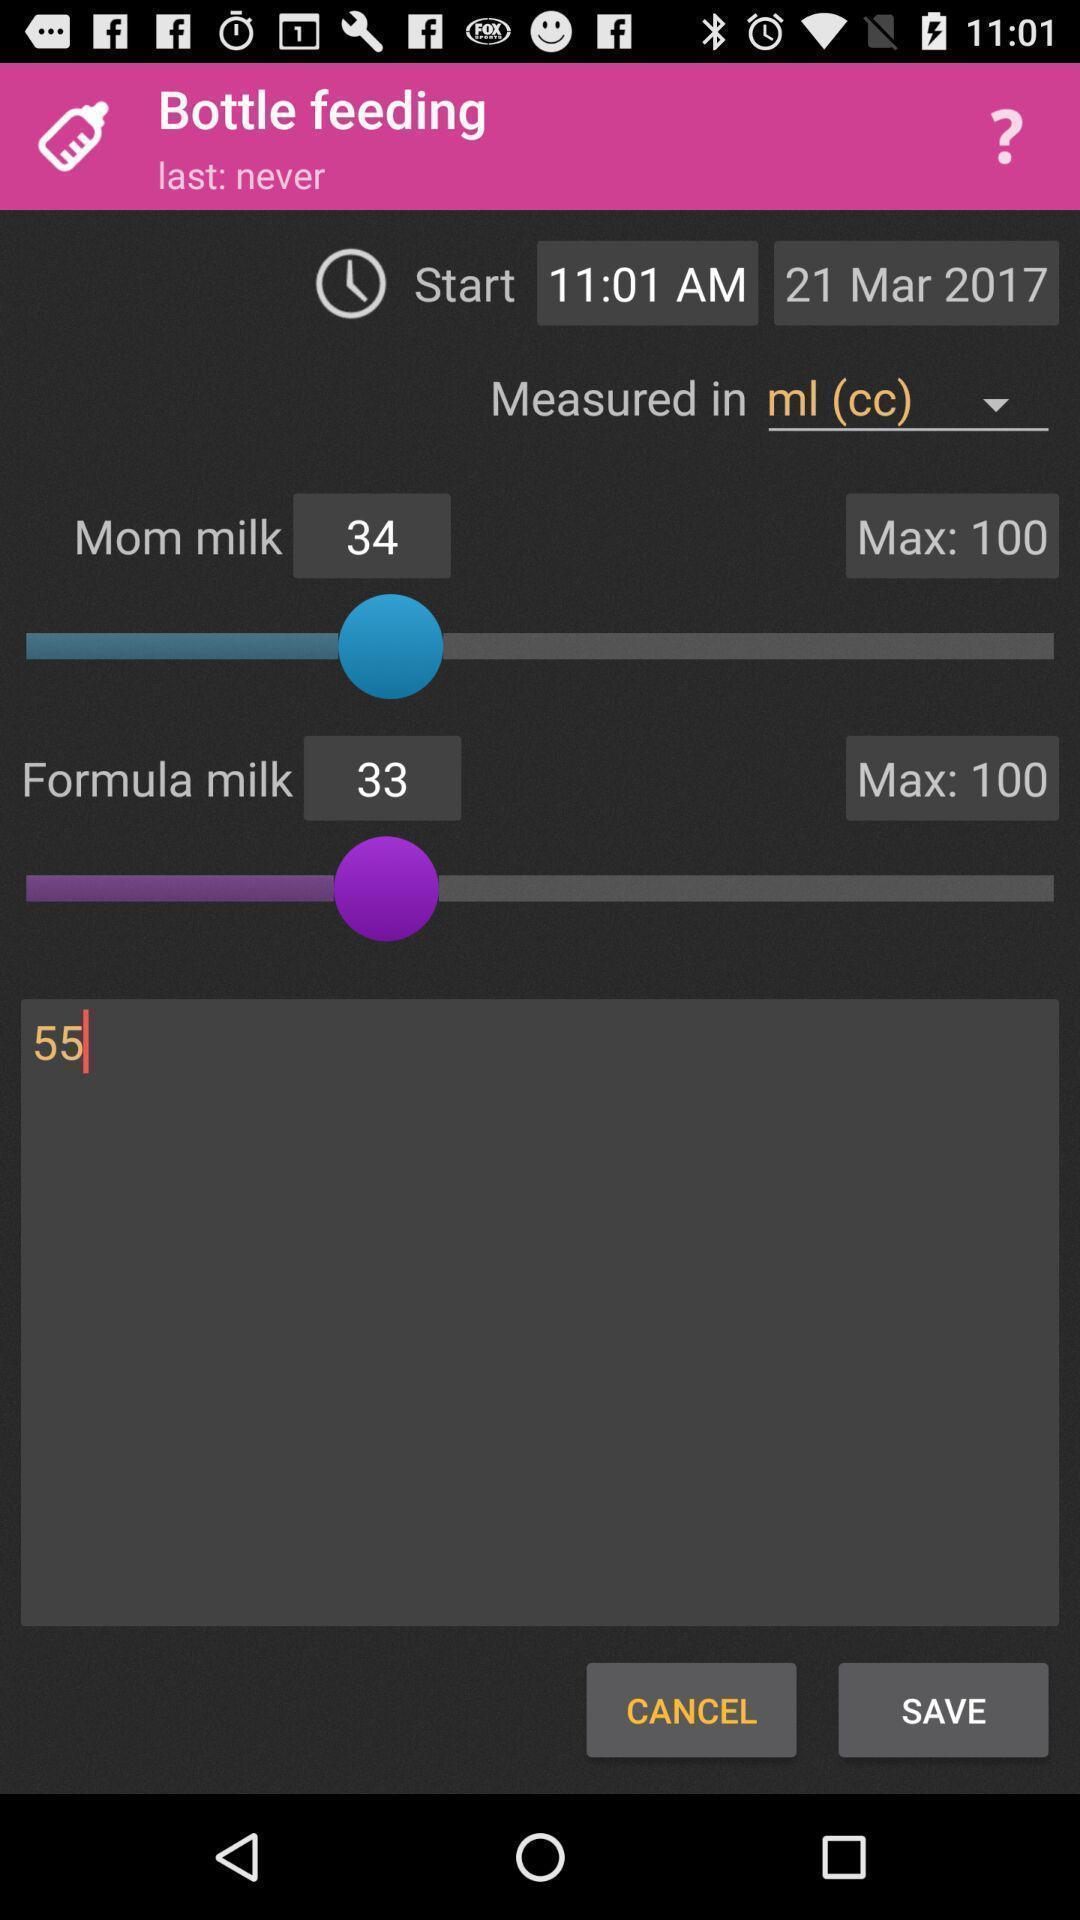Explain the elements present in this screenshot. Screen displaying the page of a medical app. 